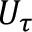Convert formula to latex. <formula><loc_0><loc_0><loc_500><loc_500>U _ { \tau }</formula> 